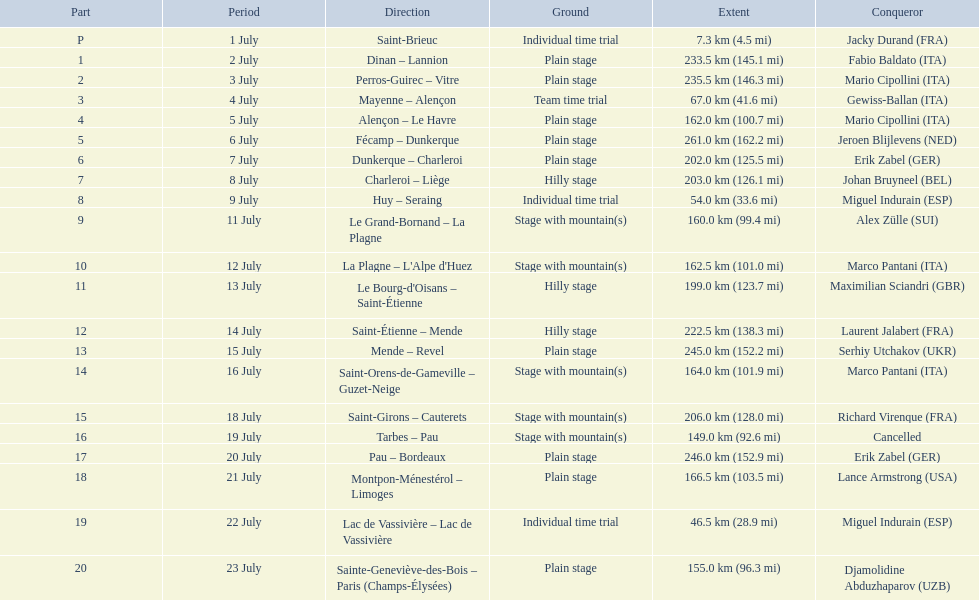After lance armstrong, who led next in the 1995 tour de france? Miguel Indurain. 